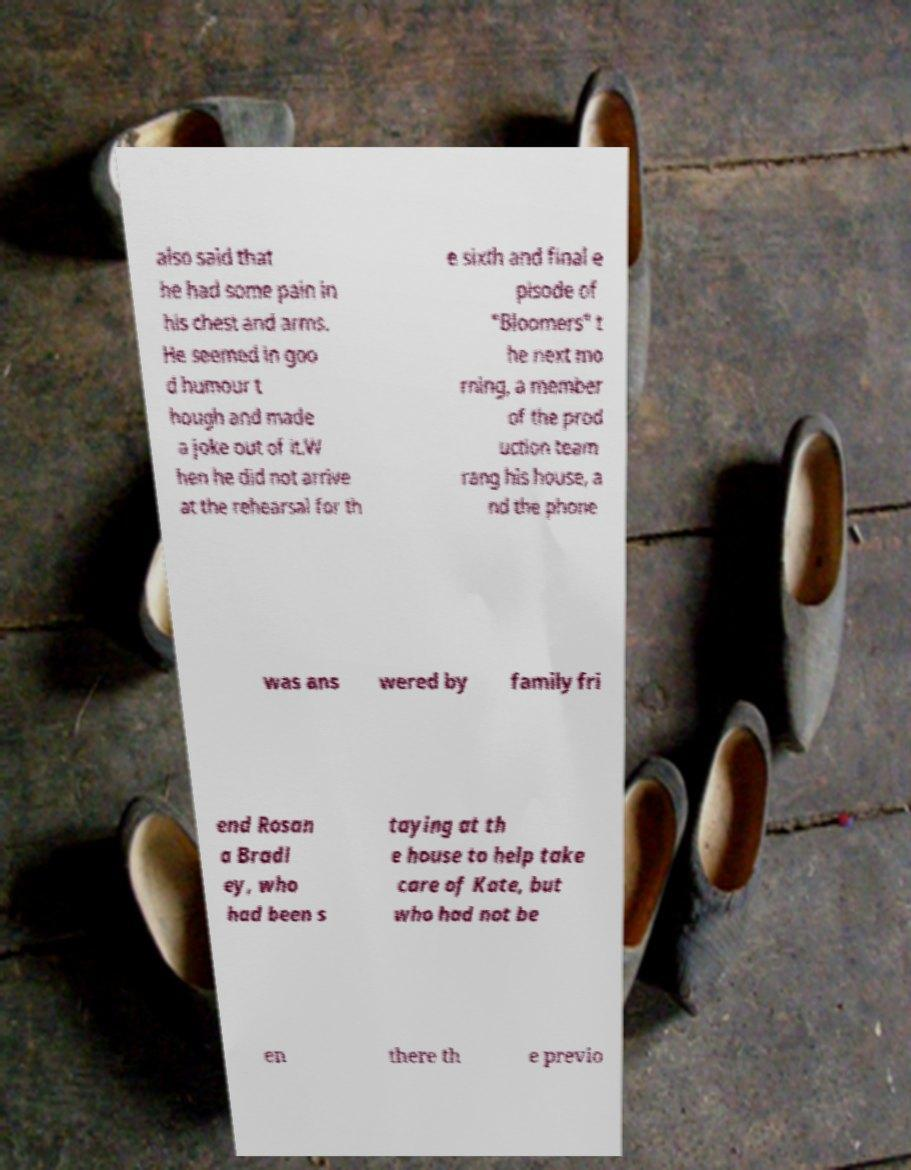I need the written content from this picture converted into text. Can you do that? also said that he had some pain in his chest and arms. He seemed in goo d humour t hough and made a joke out of it.W hen he did not arrive at the rehearsal for th e sixth and final e pisode of "Bloomers" t he next mo rning, a member of the prod uction team rang his house, a nd the phone was ans wered by family fri end Rosan a Bradl ey, who had been s taying at th e house to help take care of Kate, but who had not be en there th e previo 